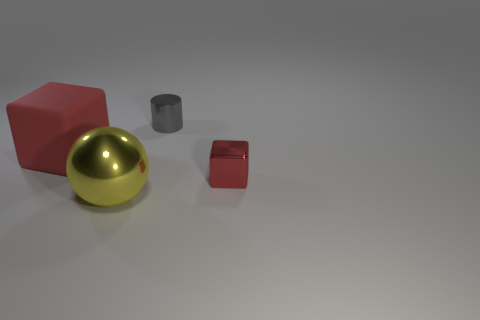Add 1 small red cubes. How many objects exist? 5 Subtract all cylinders. How many objects are left? 3 Add 2 shiny balls. How many shiny balls are left? 3 Add 4 big metal spheres. How many big metal spheres exist? 5 Subtract 1 red cubes. How many objects are left? 3 Subtract all purple cylinders. Subtract all gray shiny things. How many objects are left? 3 